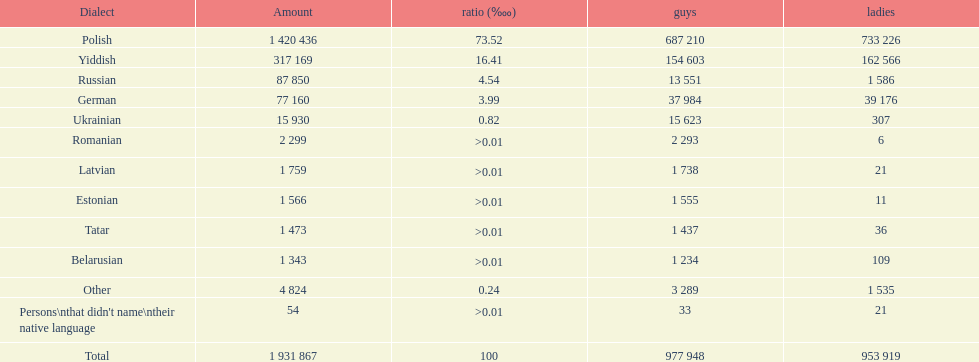Is german above or below russia in the number of people who speak that language? Below. Would you mind parsing the complete table? {'header': ['Dialect', 'Amount', 'ratio (‱)', 'guys', 'ladies'], 'rows': [['Polish', '1 420 436', '73.52', '687 210', '733 226'], ['Yiddish', '317 169', '16.41', '154 603', '162 566'], ['Russian', '87 850', '4.54', '13 551', '1 586'], ['German', '77 160', '3.99', '37 984', '39 176'], ['Ukrainian', '15 930', '0.82', '15 623', '307'], ['Romanian', '2 299', '>0.01', '2 293', '6'], ['Latvian', '1 759', '>0.01', '1 738', '21'], ['Estonian', '1 566', '>0.01', '1 555', '11'], ['Tatar', '1 473', '>0.01', '1 437', '36'], ['Belarusian', '1 343', '>0.01', '1 234', '109'], ['Other', '4 824', '0.24', '3 289', '1 535'], ["Persons\\nthat didn't name\\ntheir native language", '54', '>0.01', '33', '21'], ['Total', '1 931 867', '100', '977 948', '953 919']]} 